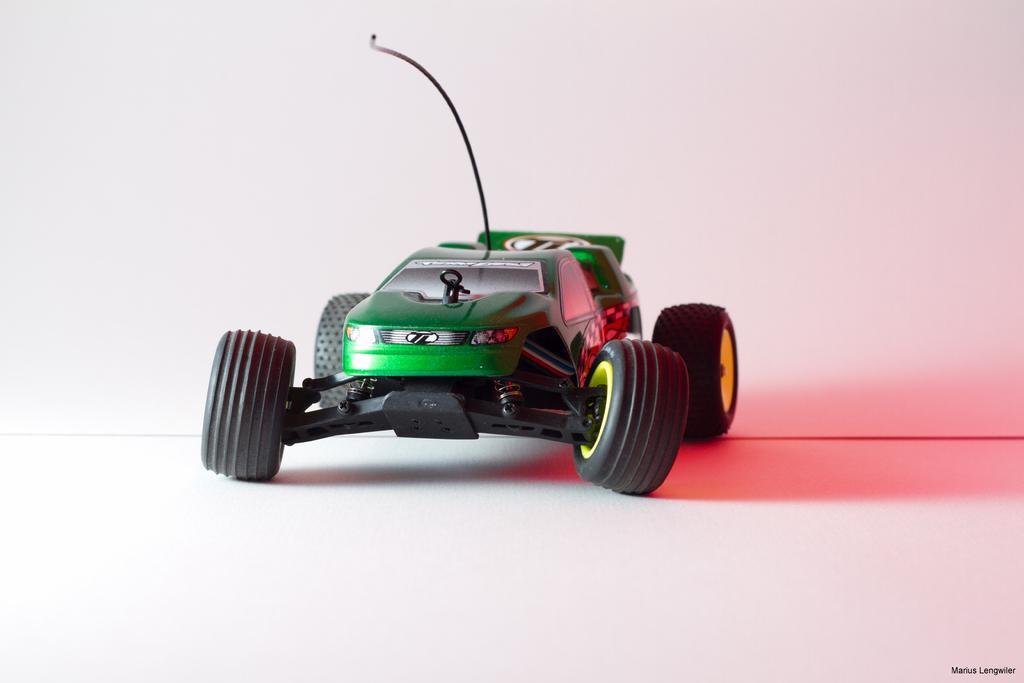Describe this image in one or two sentences. This is a picture of a toy. This toy name is called Hot-wheel. It has Tyre, Wheel, Headlight and Antenna. It is in green color the tyres are in black and there is a background of white wall. 